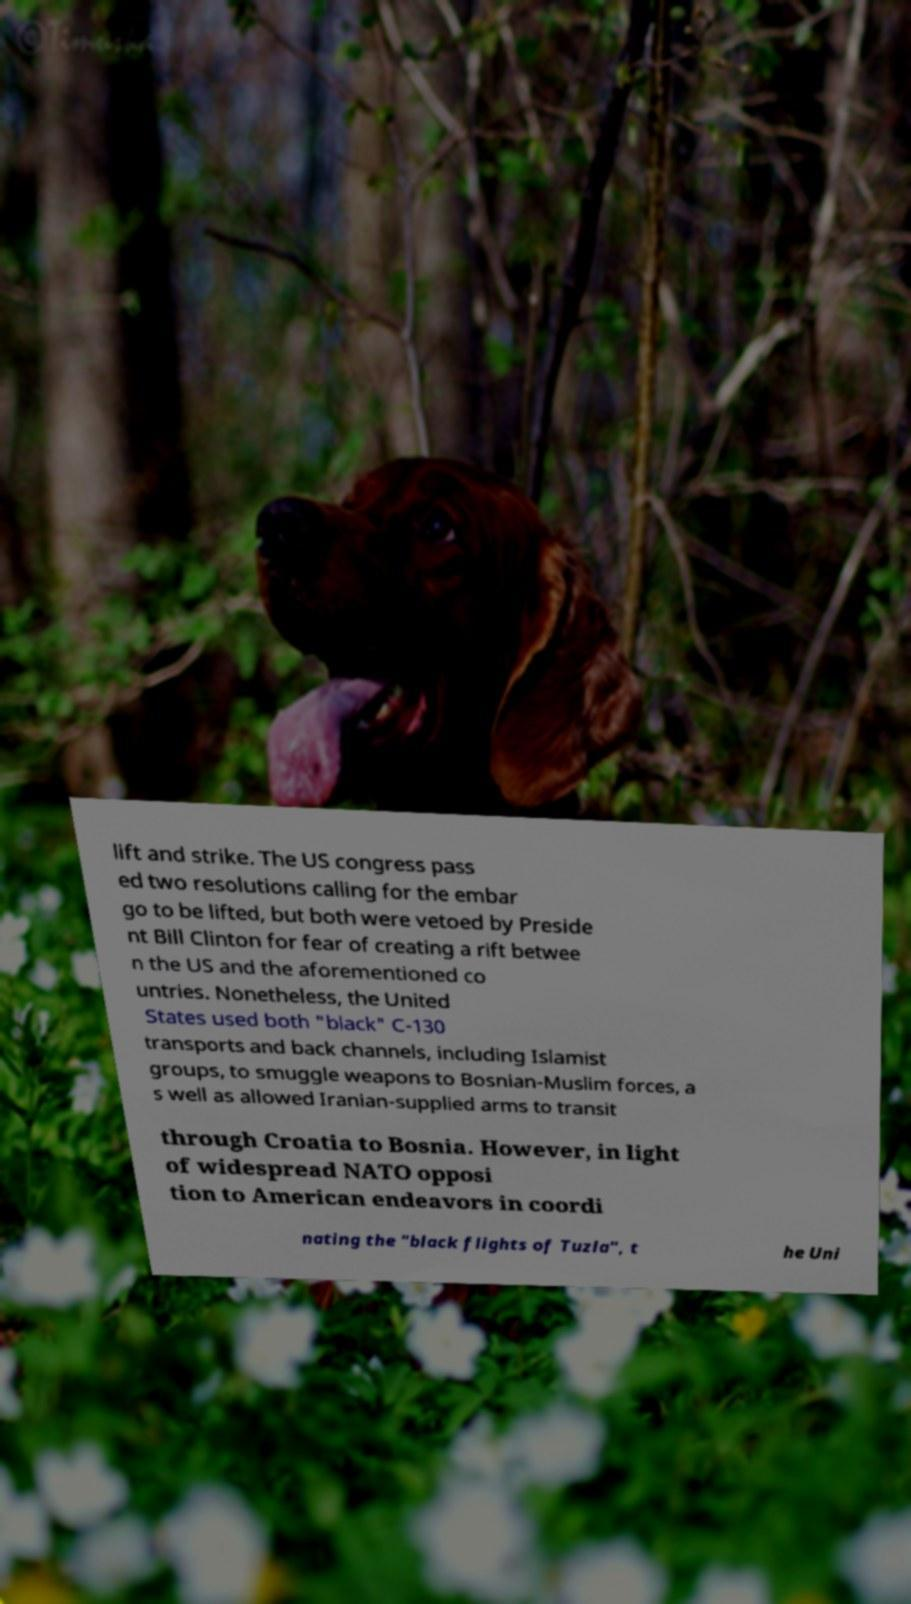Please read and relay the text visible in this image. What does it say? lift and strike. The US congress pass ed two resolutions calling for the embar go to be lifted, but both were vetoed by Preside nt Bill Clinton for fear of creating a rift betwee n the US and the aforementioned co untries. Nonetheless, the United States used both "black" C-130 transports and back channels, including Islamist groups, to smuggle weapons to Bosnian-Muslim forces, a s well as allowed Iranian-supplied arms to transit through Croatia to Bosnia. However, in light of widespread NATO opposi tion to American endeavors in coordi nating the "black flights of Tuzla", t he Uni 